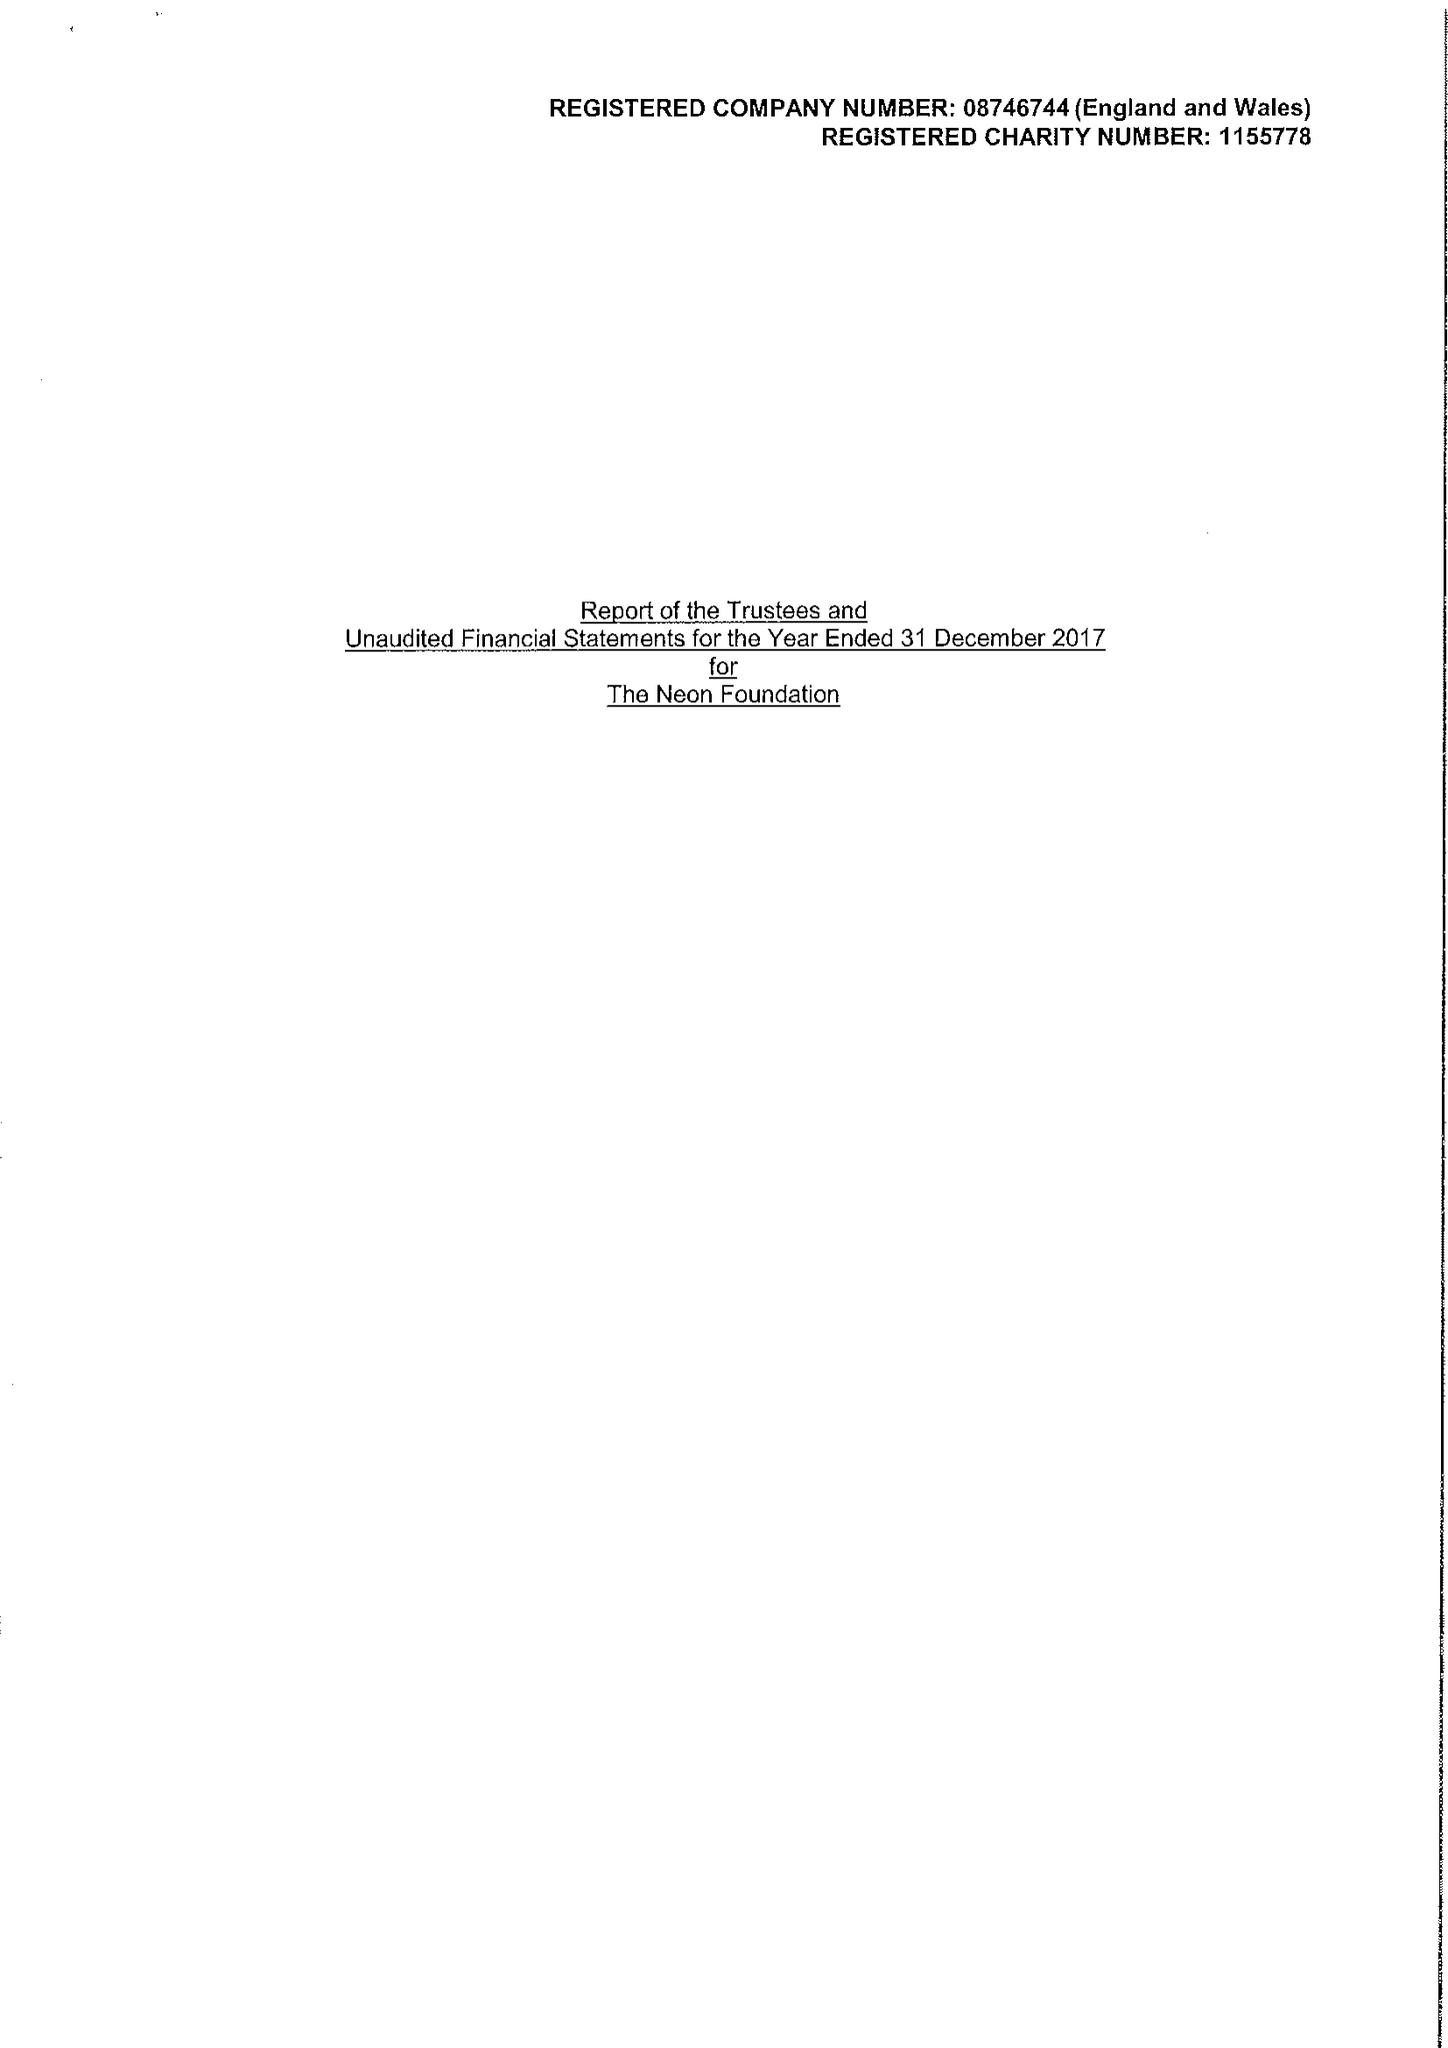What is the value for the address__postcode?
Answer the question using a single word or phrase. EC1R 3DG 